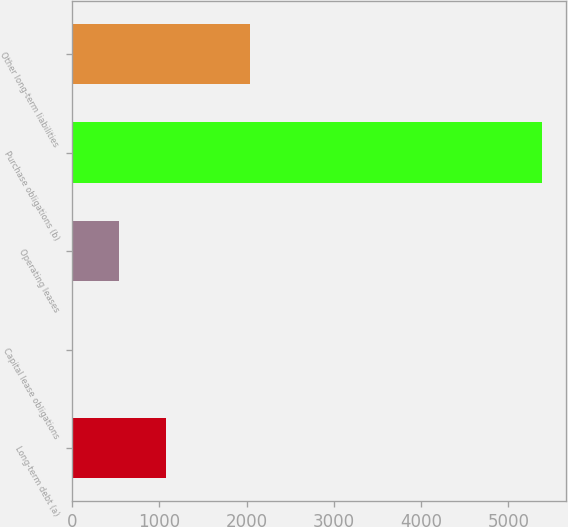<chart> <loc_0><loc_0><loc_500><loc_500><bar_chart><fcel>Long-term debt (a)<fcel>Capital lease obligations<fcel>Operating leases<fcel>Purchase obligations (b)<fcel>Other long-term liabilities<nl><fcel>1080.2<fcel>4<fcel>542.1<fcel>5385<fcel>2035<nl></chart> 